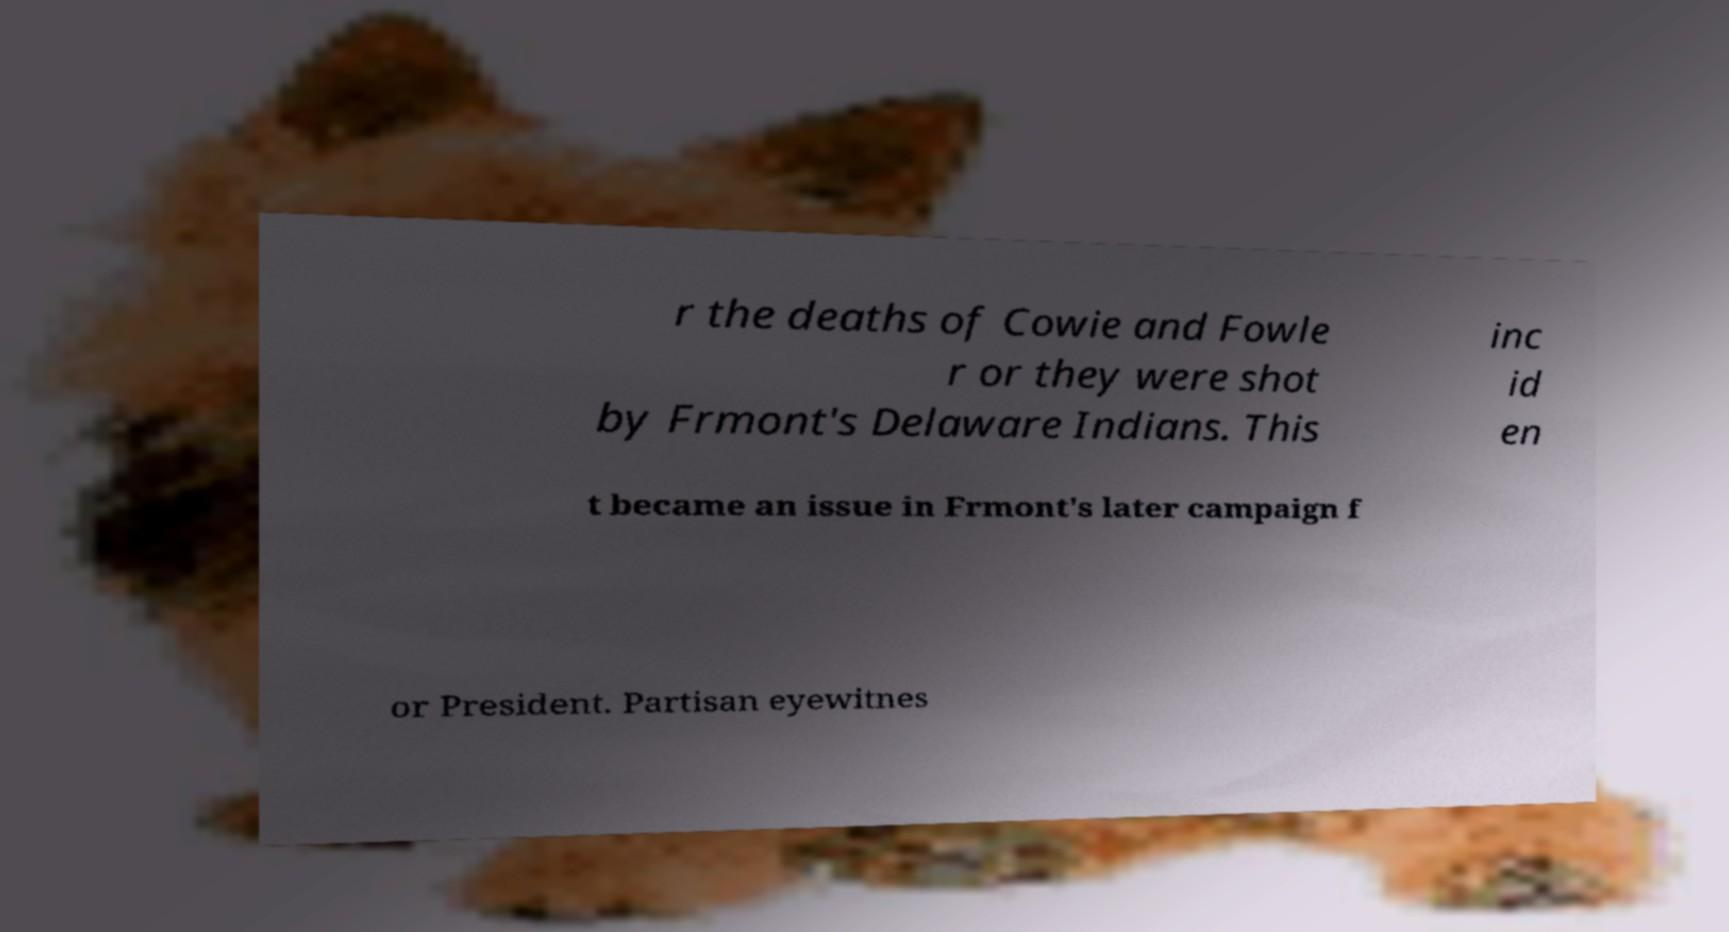Could you extract and type out the text from this image? r the deaths of Cowie and Fowle r or they were shot by Frmont's Delaware Indians. This inc id en t became an issue in Frmont's later campaign f or President. Partisan eyewitnes 